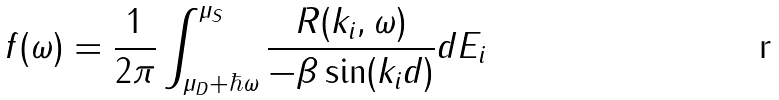<formula> <loc_0><loc_0><loc_500><loc_500>f ( \omega ) = \frac { 1 } { 2 \pi } \int _ { \mu _ { D } + \hbar { \omega } } ^ { \mu _ { S } } \frac { R ( k _ { i } , \omega ) } { - \beta \sin ( k _ { i } d ) } d E _ { i }</formula> 